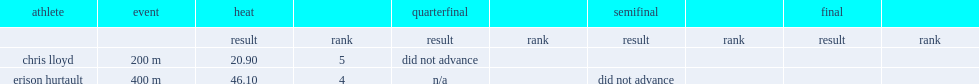What was the result that erison hurtault got in the heat? 46.1. 